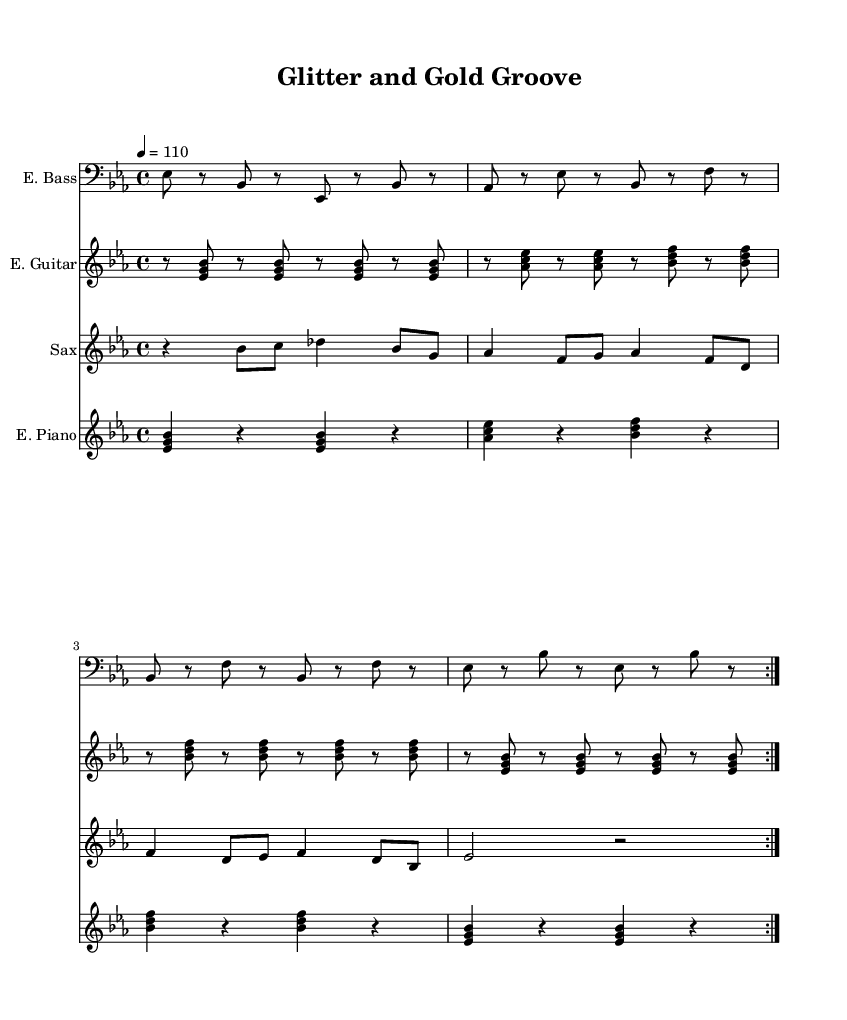What is the key signature of this music? The key signature is Es major, indicated by three flats (Bb, Eb, Ab) in the key signature box at the beginning of the staff.
Answer: Es major What is the time signature of this music? The time signature is 4/4, shown at the start of the score where it specifies that there are four beats in each measure and the quarter note gets one beat.
Answer: 4/4 What is the tempo marking of this piece? The tempo marking is 4 = 110, which indicates that there are 110 beats per minute with each quarter note receiving one beat.
Answer: 110 Which instrument plays the saxophone parts? The saxophone is specified in the staff labeled as "Sax", indicating that this is where the saxophone music is written.
Answer: Sax How many measures are repeated in the electric bass line? The electric bass line has a repeat sign that indicates the section should be played twice, encompassing the two measures that have been specified.
Answer: 2 Which instrument features rhythmic chords? The electric guitar features rhythmic chords, as shown by the chord symbols written in the guitar staff and its distinct rhythm with sustained notes.
Answer: Electric Guitar What is the overall genre of this music? The genre of this music is identified as Funk, which is characterized by its groovy rhythmic feel and the presence of the saxophone and other popular funk instrumentation throughout the arrangement.
Answer: Funk 